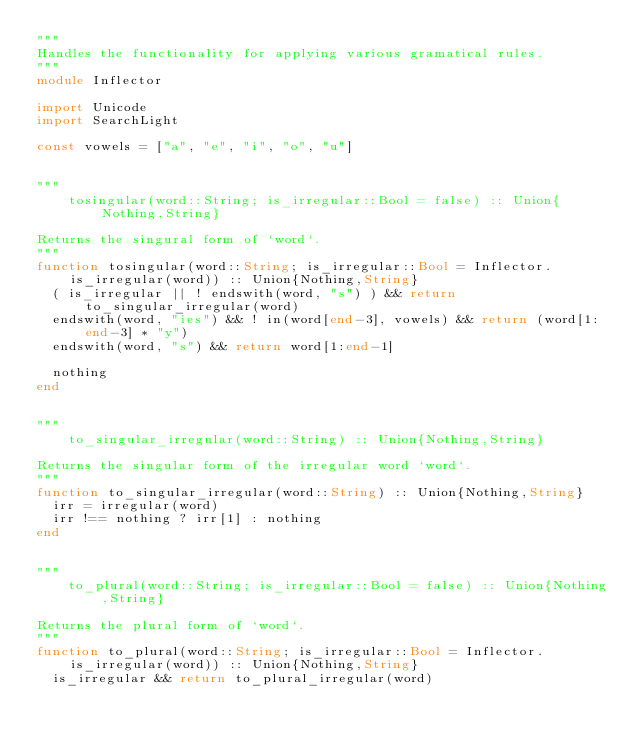Convert code to text. <code><loc_0><loc_0><loc_500><loc_500><_Julia_>"""
Handles the functionality for applying various gramatical rules.
"""
module Inflector

import Unicode
import SearchLight

const vowels = ["a", "e", "i", "o", "u"]


"""
    tosingular(word::String; is_irregular::Bool = false) :: Union{Nothing,String}

Returns the singural form of `word`.
"""
function tosingular(word::String; is_irregular::Bool = Inflector.is_irregular(word)) :: Union{Nothing,String}
  ( is_irregular || ! endswith(word, "s") ) && return to_singular_irregular(word)
  endswith(word, "ies") && ! in(word[end-3], vowels) && return (word[1:end-3] * "y")
  endswith(word, "s") && return word[1:end-1]

  nothing
end


"""
    to_singular_irregular(word::String) :: Union{Nothing,String}

Returns the singular form of the irregular word `word`.
"""
function to_singular_irregular(word::String) :: Union{Nothing,String}
  irr = irregular(word)
  irr !== nothing ? irr[1] : nothing
end


"""
    to_plural(word::String; is_irregular::Bool = false) :: Union{Nothing,String}

Returns the plural form of `word`.
"""
function to_plural(word::String; is_irregular::Bool = Inflector.is_irregular(word)) :: Union{Nothing,String}
  is_irregular && return to_plural_irregular(word)</code> 